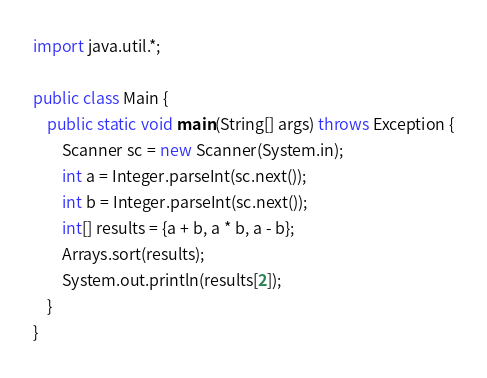Convert code to text. <code><loc_0><loc_0><loc_500><loc_500><_Java_>import java.util.*;

public class Main {
    public static void main(String[] args) throws Exception {
        Scanner sc = new Scanner(System.in);
        int a = Integer.parseInt(sc.next());
        int b = Integer.parseInt(sc.next());
        int[] results = {a + b, a * b, a - b};
        Arrays.sort(results);
        System.out.println(results[2]);
    }
}
</code> 